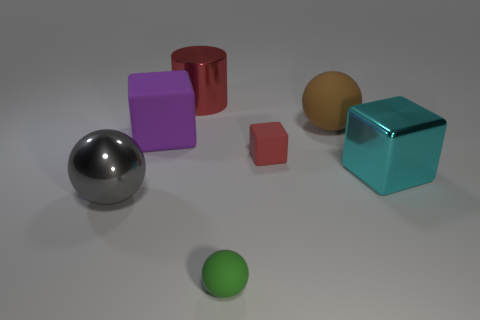This setup looks very clean and simplistic. What uses might such an image have? Images like this are typically utilized for 3D modeling and rendering demonstrations. They offer a controlled environment to test lighting, shadows, and materials. Graphic designers, animators, and students often use such images for practice or to showcase rendering skills. What do the lighting and shadows tell us about the environment? The even lighting and soft shadows suggest an indoor setting with diffuse light sources, imitating natural light. It creates a calm atmosphere and provides a clear view of the objects' dimensions and the interactions of light with their surfaces. 